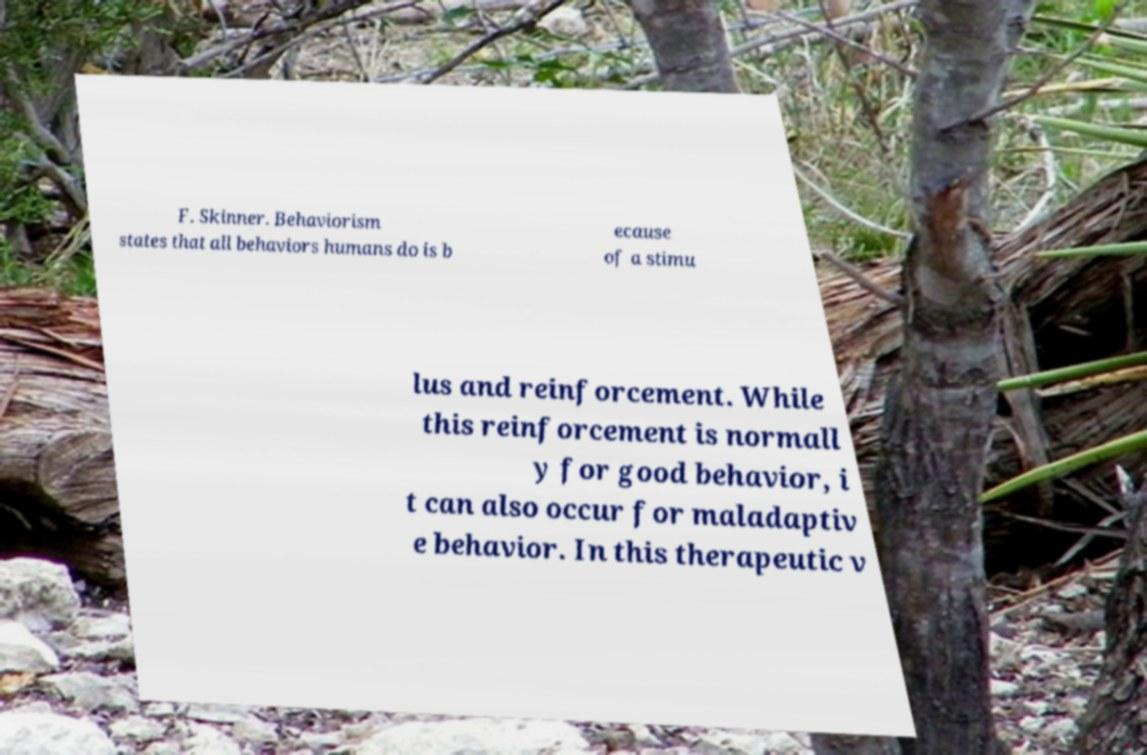Please read and relay the text visible in this image. What does it say? F. Skinner. Behaviorism states that all behaviors humans do is b ecause of a stimu lus and reinforcement. While this reinforcement is normall y for good behavior, i t can also occur for maladaptiv e behavior. In this therapeutic v 